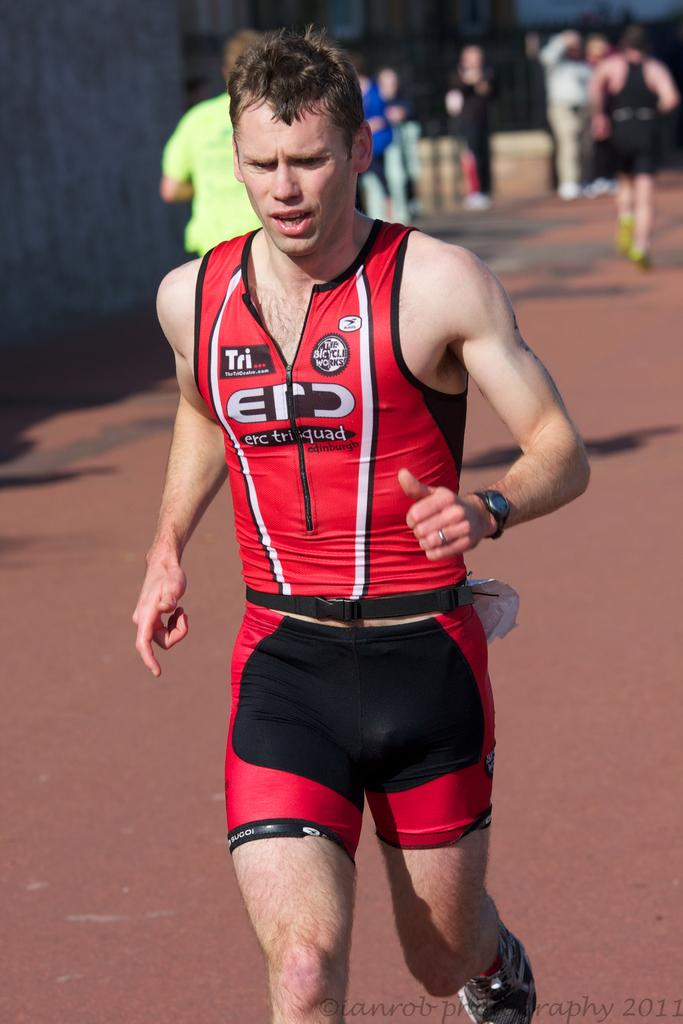Provide a one-sentence caption for the provided image. a man running a marathon with a shirt from thetricentre.com. 